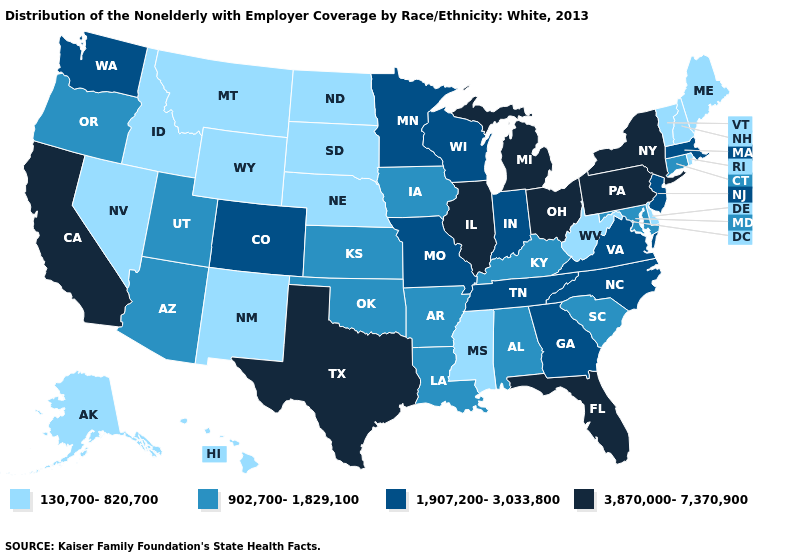What is the lowest value in the USA?
Short answer required. 130,700-820,700. Which states have the lowest value in the USA?
Keep it brief. Alaska, Delaware, Hawaii, Idaho, Maine, Mississippi, Montana, Nebraska, Nevada, New Hampshire, New Mexico, North Dakota, Rhode Island, South Dakota, Vermont, West Virginia, Wyoming. Does Vermont have the highest value in the USA?
Quick response, please. No. What is the value of Pennsylvania?
Keep it brief. 3,870,000-7,370,900. What is the value of Alaska?
Concise answer only. 130,700-820,700. Name the states that have a value in the range 902,700-1,829,100?
Answer briefly. Alabama, Arizona, Arkansas, Connecticut, Iowa, Kansas, Kentucky, Louisiana, Maryland, Oklahoma, Oregon, South Carolina, Utah. Does Illinois have the highest value in the MidWest?
Short answer required. Yes. What is the value of California?
Give a very brief answer. 3,870,000-7,370,900. What is the value of Massachusetts?
Answer briefly. 1,907,200-3,033,800. Name the states that have a value in the range 1,907,200-3,033,800?
Answer briefly. Colorado, Georgia, Indiana, Massachusetts, Minnesota, Missouri, New Jersey, North Carolina, Tennessee, Virginia, Washington, Wisconsin. Which states have the highest value in the USA?
Keep it brief. California, Florida, Illinois, Michigan, New York, Ohio, Pennsylvania, Texas. What is the value of Michigan?
Write a very short answer. 3,870,000-7,370,900. Name the states that have a value in the range 130,700-820,700?
Short answer required. Alaska, Delaware, Hawaii, Idaho, Maine, Mississippi, Montana, Nebraska, Nevada, New Hampshire, New Mexico, North Dakota, Rhode Island, South Dakota, Vermont, West Virginia, Wyoming. Does Hawaii have the lowest value in the West?
Short answer required. Yes. 